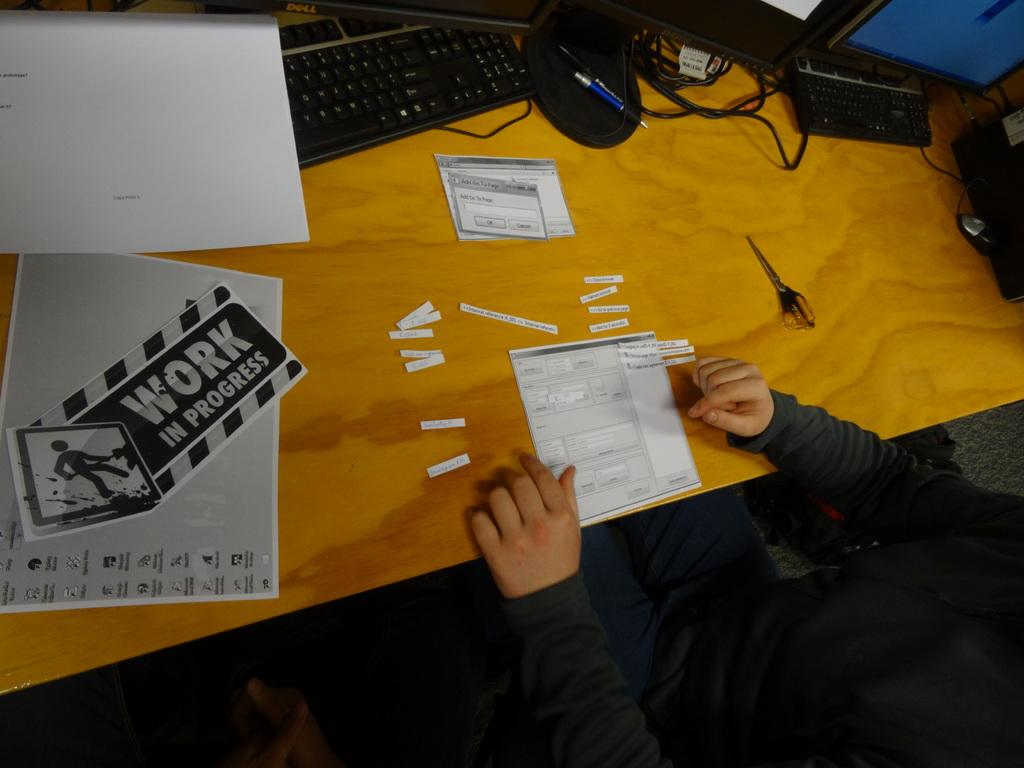<image>
Describe the image concisely. Two hands on a desk and a sign on the left reading Work in Progress. 